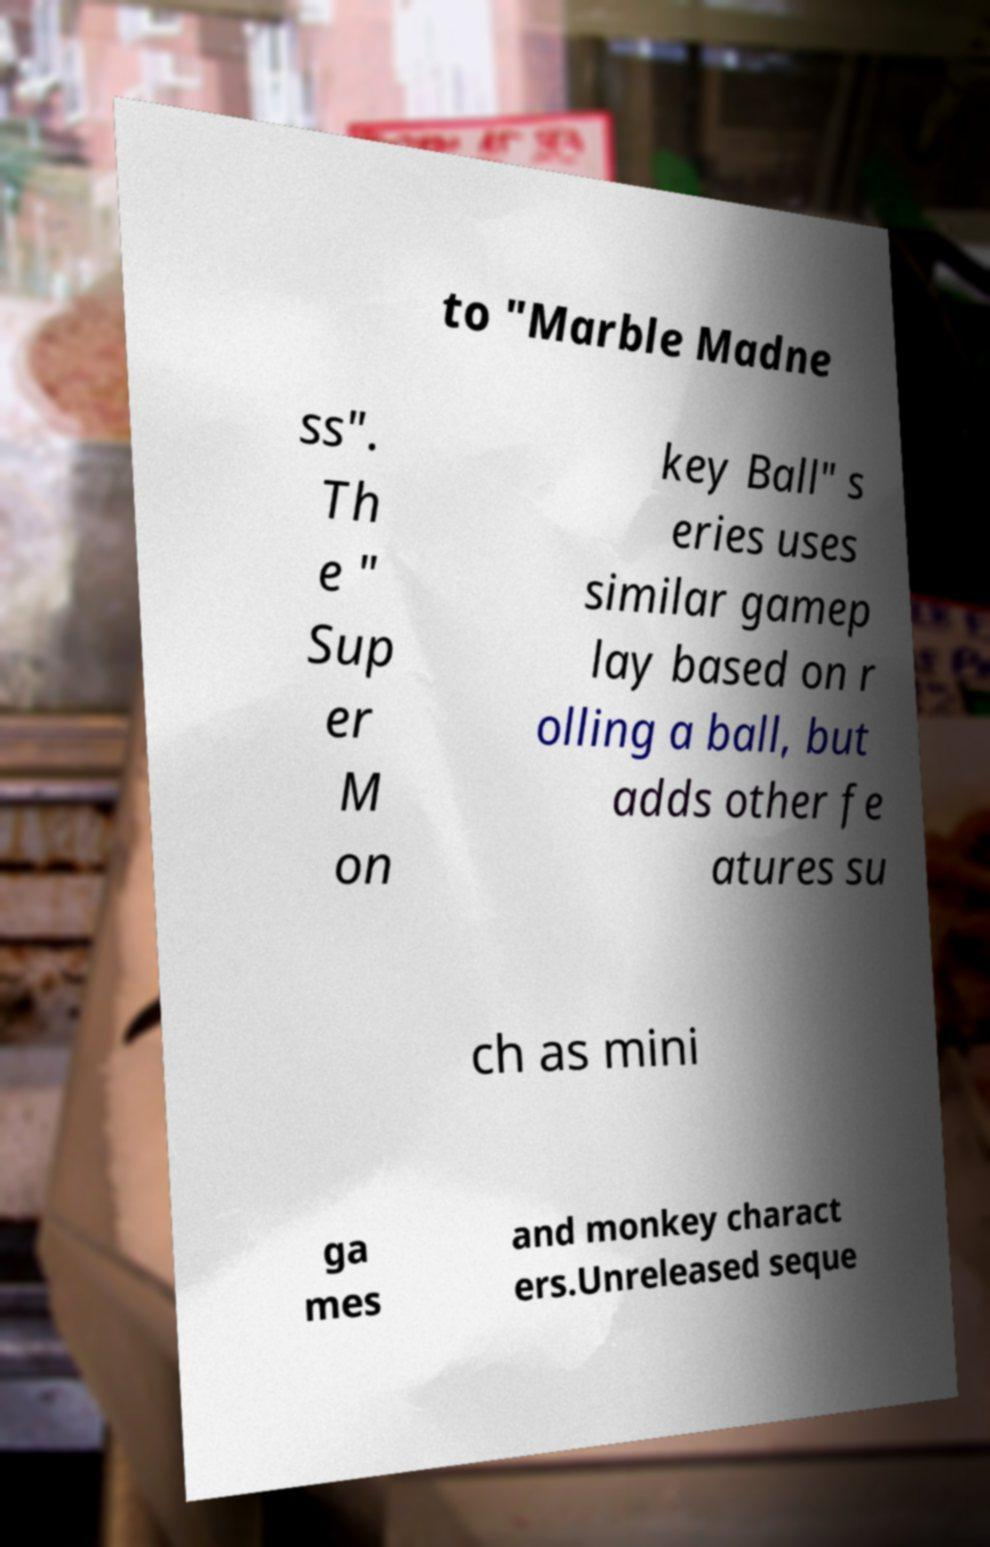There's text embedded in this image that I need extracted. Can you transcribe it verbatim? to "Marble Madne ss". Th e " Sup er M on key Ball" s eries uses similar gamep lay based on r olling a ball, but adds other fe atures su ch as mini ga mes and monkey charact ers.Unreleased seque 